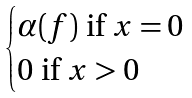<formula> <loc_0><loc_0><loc_500><loc_500>\begin{cases} \alpha ( f ) \text { if } x = 0 \\ 0 \text { if } x > 0 \end{cases}</formula> 